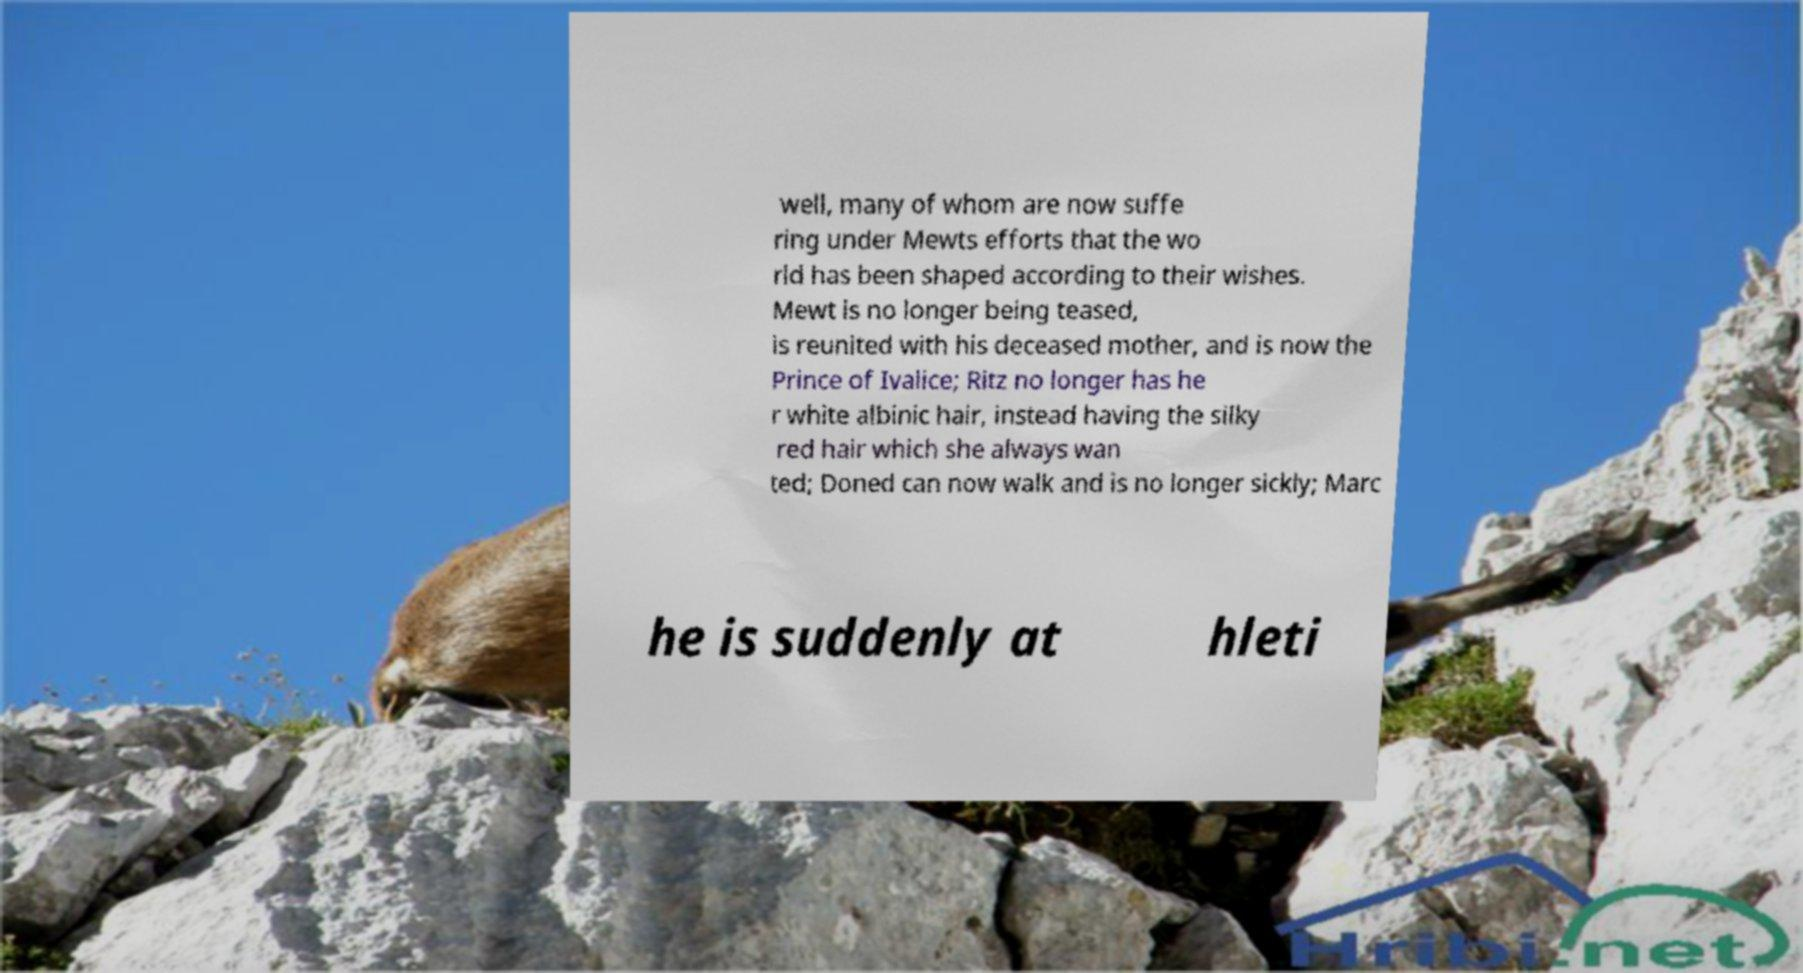Can you read and provide the text displayed in the image?This photo seems to have some interesting text. Can you extract and type it out for me? well, many of whom are now suffe ring under Mewts efforts that the wo rld has been shaped according to their wishes. Mewt is no longer being teased, is reunited with his deceased mother, and is now the Prince of Ivalice; Ritz no longer has he r white albinic hair, instead having the silky red hair which she always wan ted; Doned can now walk and is no longer sickly; Marc he is suddenly at hleti 